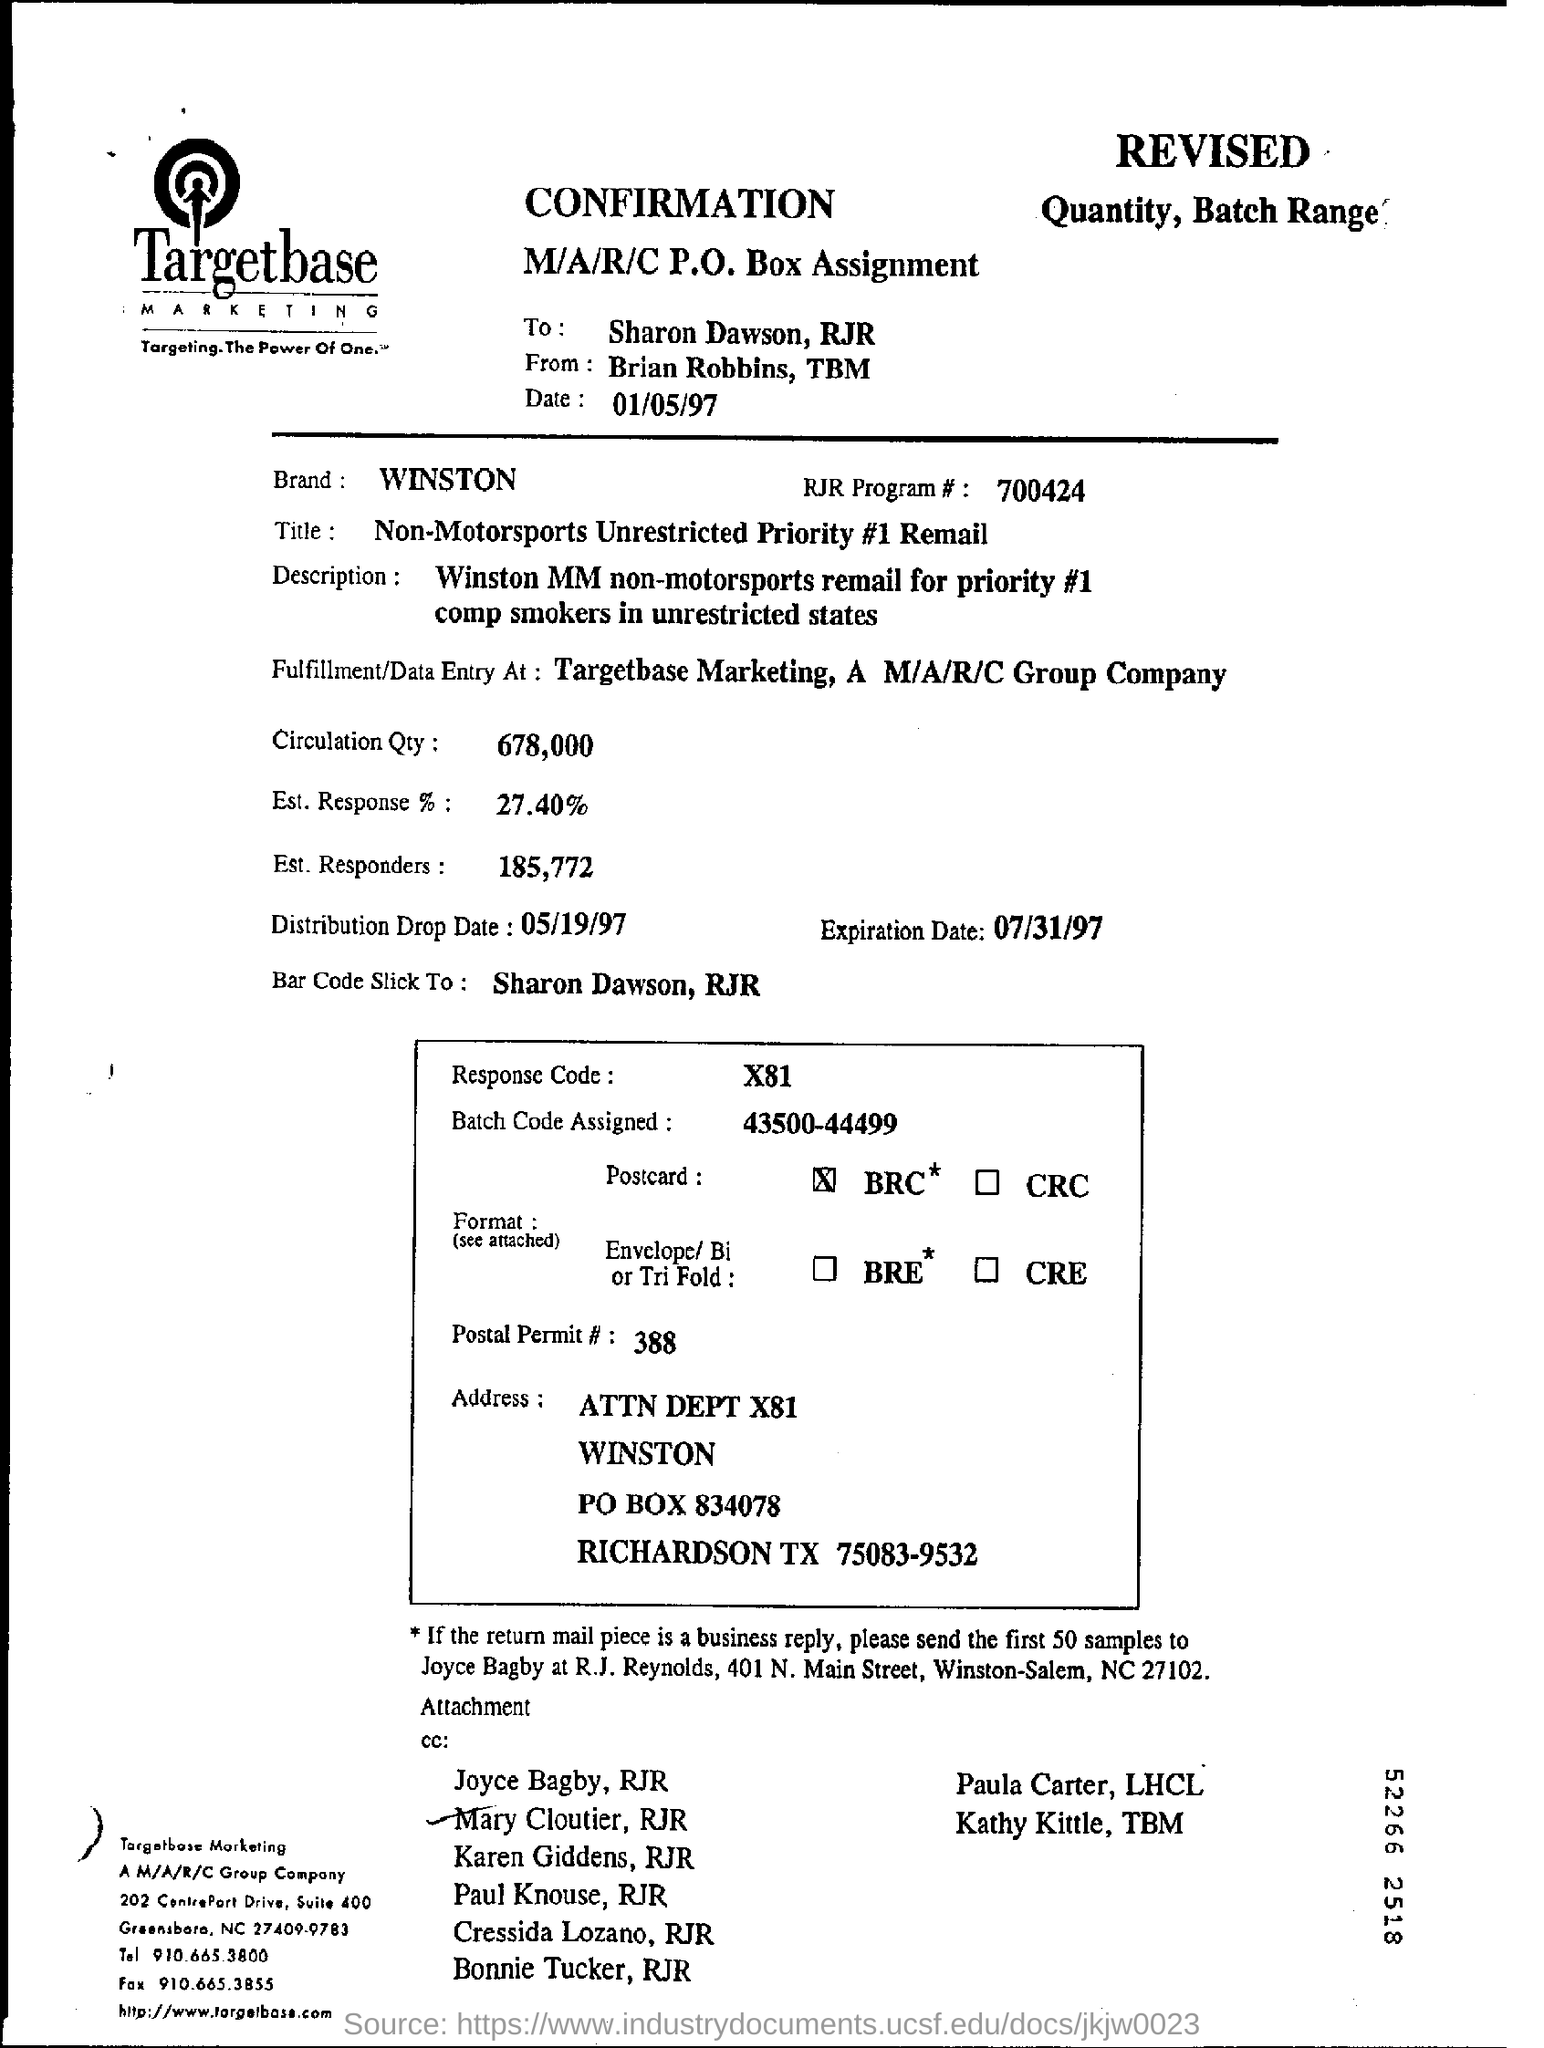Which Brand is given in this document?
Provide a succinct answer. WINSTON. What is the RJR Program # no?
Your response must be concise. 700424. What is the Circulation Qty as per the document?
Your answer should be compact. 678,000. What is the Est. Response %  as per the document?
Your response must be concise. 27.40. How many Est. Responders are there as per the document?
Your answer should be very brief. 185,772. What is the Batch Code Assigned?
Your answer should be compact. 43500-444999. What is the Expiration date mentioned in the document?
Ensure brevity in your answer.  07/31/97. 